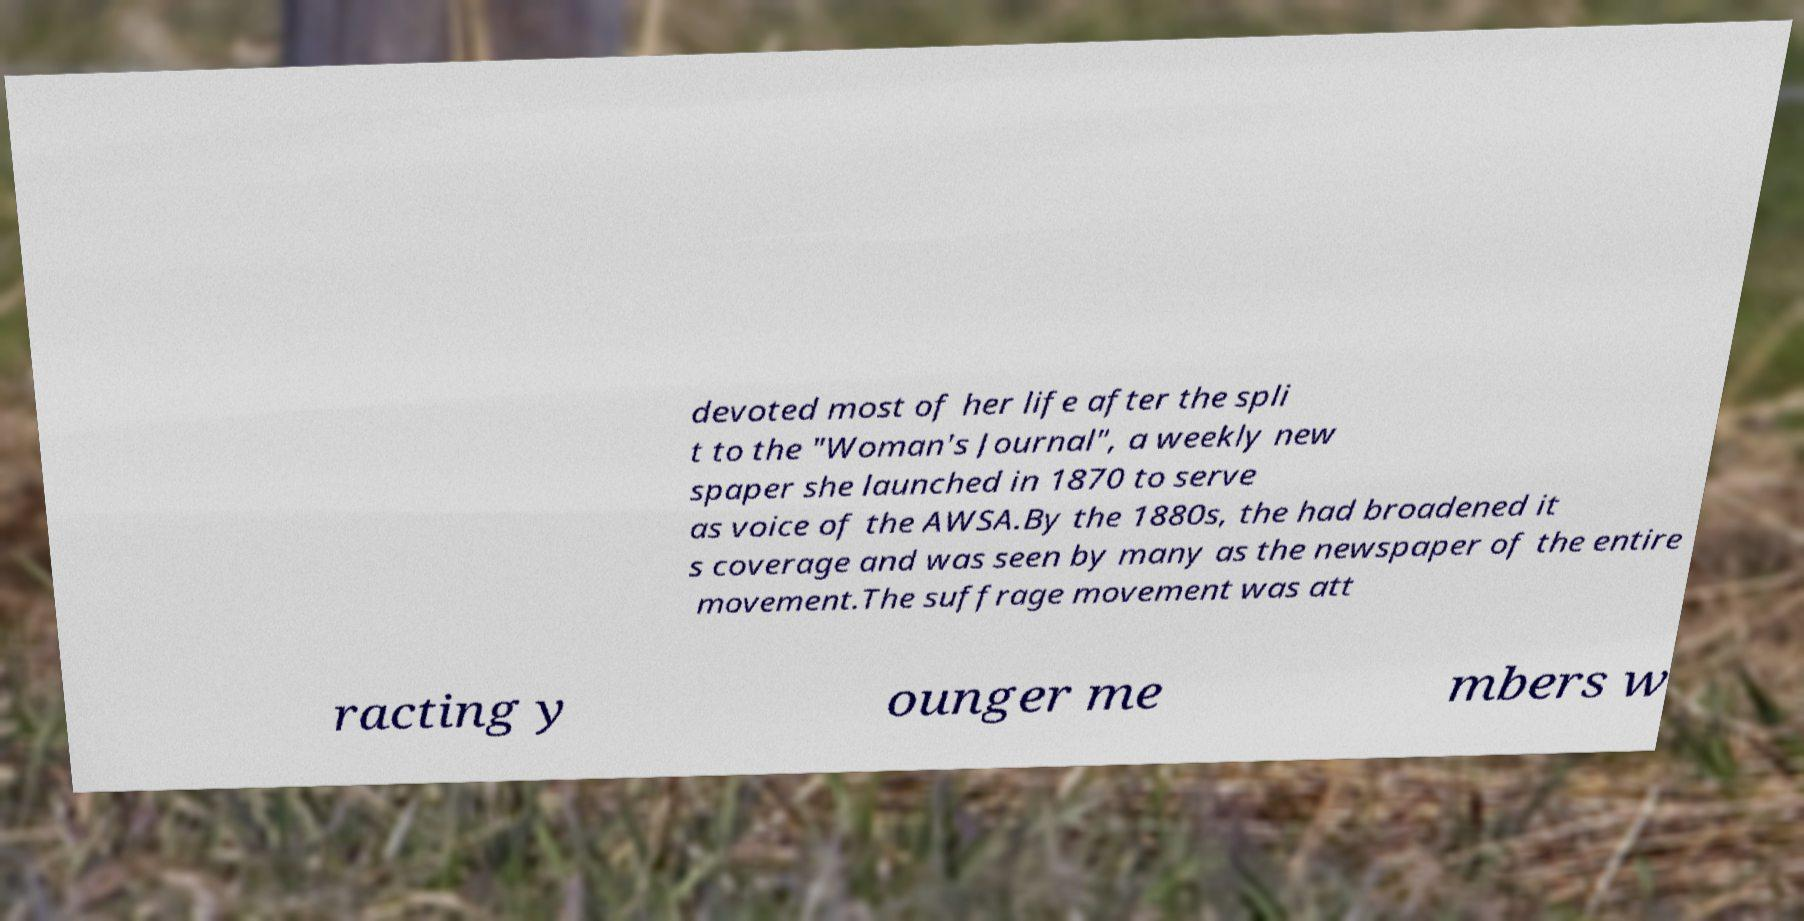Can you read and provide the text displayed in the image?This photo seems to have some interesting text. Can you extract and type it out for me? devoted most of her life after the spli t to the "Woman's Journal", a weekly new spaper she launched in 1870 to serve as voice of the AWSA.By the 1880s, the had broadened it s coverage and was seen by many as the newspaper of the entire movement.The suffrage movement was att racting y ounger me mbers w 